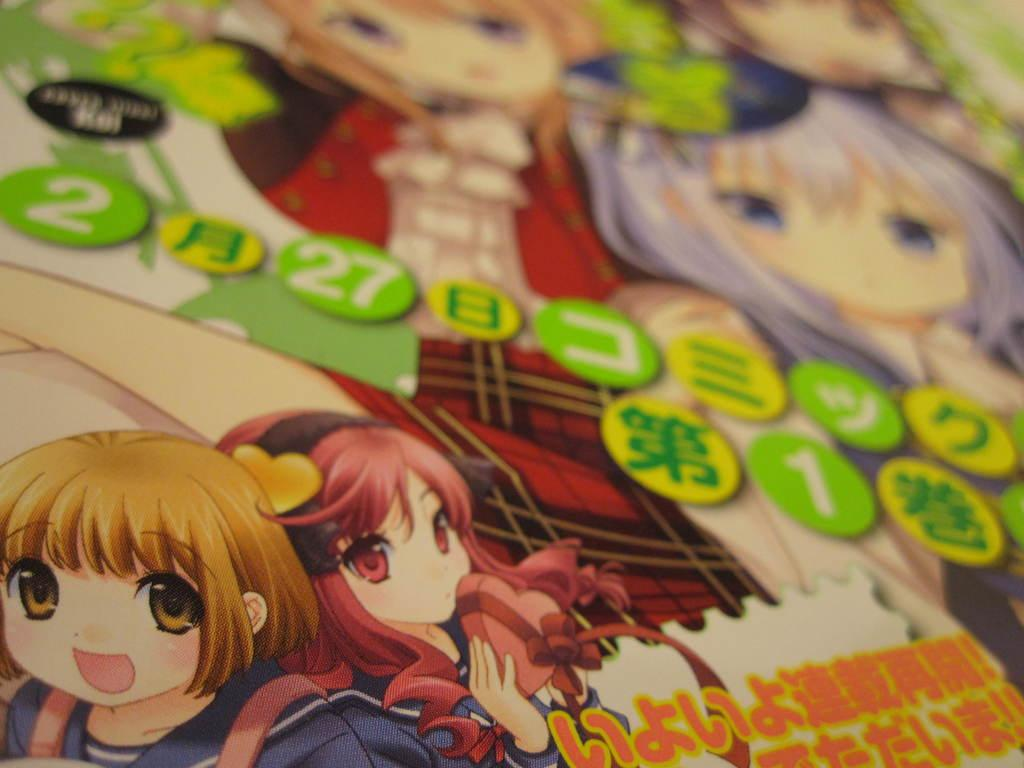What type of characters are present in the image? There are cartoon characters in the image. What else can be seen in the image besides the characters? There are numbers and text in the image. Can you tell me how many sheep are present in the image? There are no sheep present in the image; it features cartoon characters, numbers, and text. 